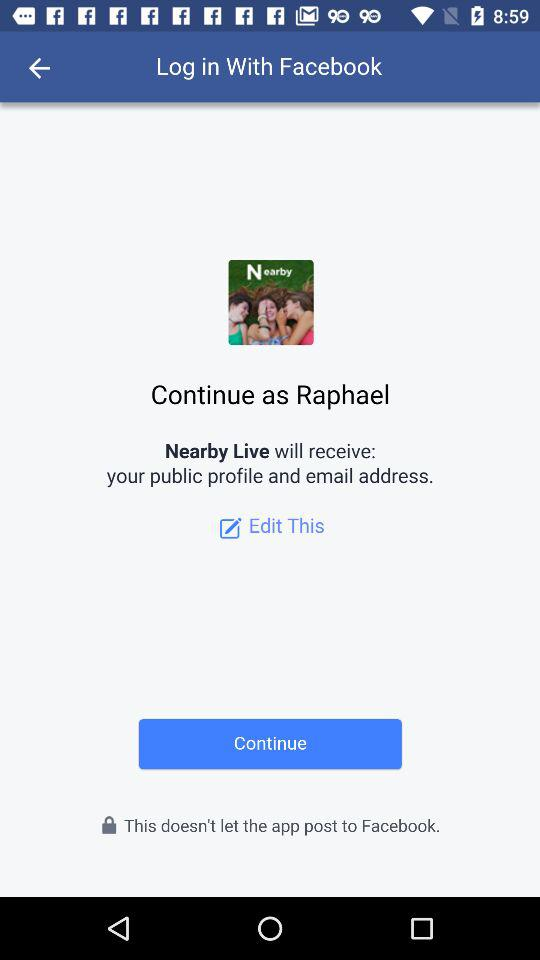What application is asking for permission? The application asking for permission is "Nearby Live". 